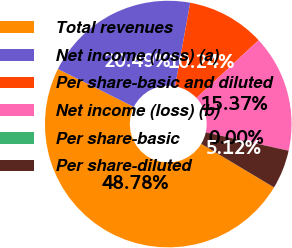<chart> <loc_0><loc_0><loc_500><loc_500><pie_chart><fcel>Total revenues<fcel>Net income (loss) (a)<fcel>Per share-basic and diluted<fcel>Net income (loss) (b)<fcel>Per share-basic<fcel>Per share-diluted<nl><fcel>48.78%<fcel>20.49%<fcel>10.24%<fcel>15.37%<fcel>0.0%<fcel>5.12%<nl></chart> 